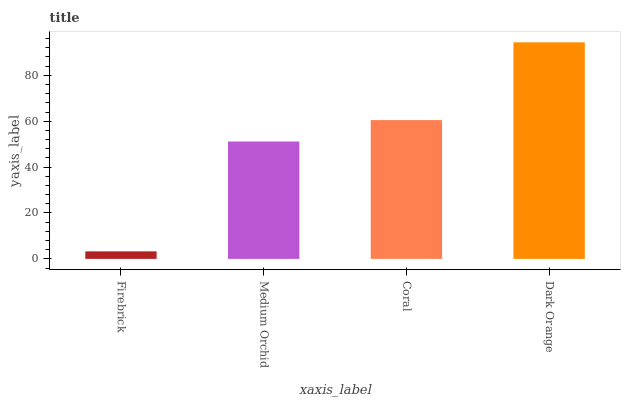Is Firebrick the minimum?
Answer yes or no. Yes. Is Dark Orange the maximum?
Answer yes or no. Yes. Is Medium Orchid the minimum?
Answer yes or no. No. Is Medium Orchid the maximum?
Answer yes or no. No. Is Medium Orchid greater than Firebrick?
Answer yes or no. Yes. Is Firebrick less than Medium Orchid?
Answer yes or no. Yes. Is Firebrick greater than Medium Orchid?
Answer yes or no. No. Is Medium Orchid less than Firebrick?
Answer yes or no. No. Is Coral the high median?
Answer yes or no. Yes. Is Medium Orchid the low median?
Answer yes or no. Yes. Is Medium Orchid the high median?
Answer yes or no. No. Is Coral the low median?
Answer yes or no. No. 